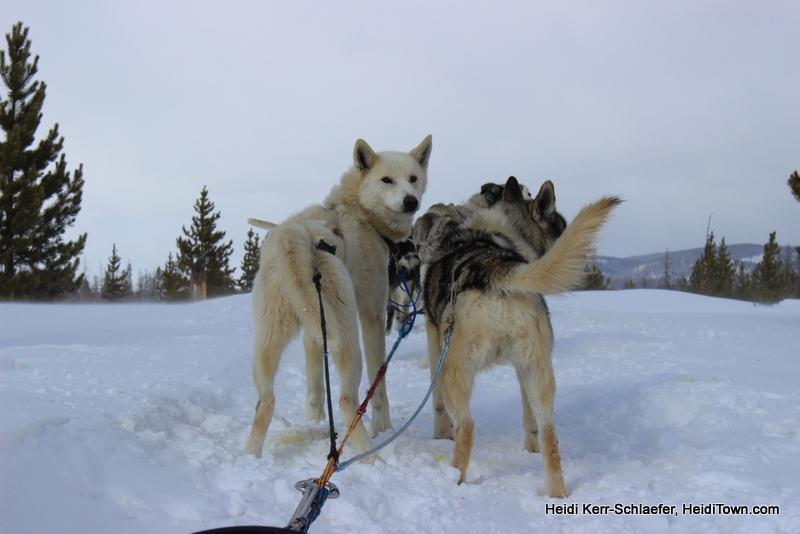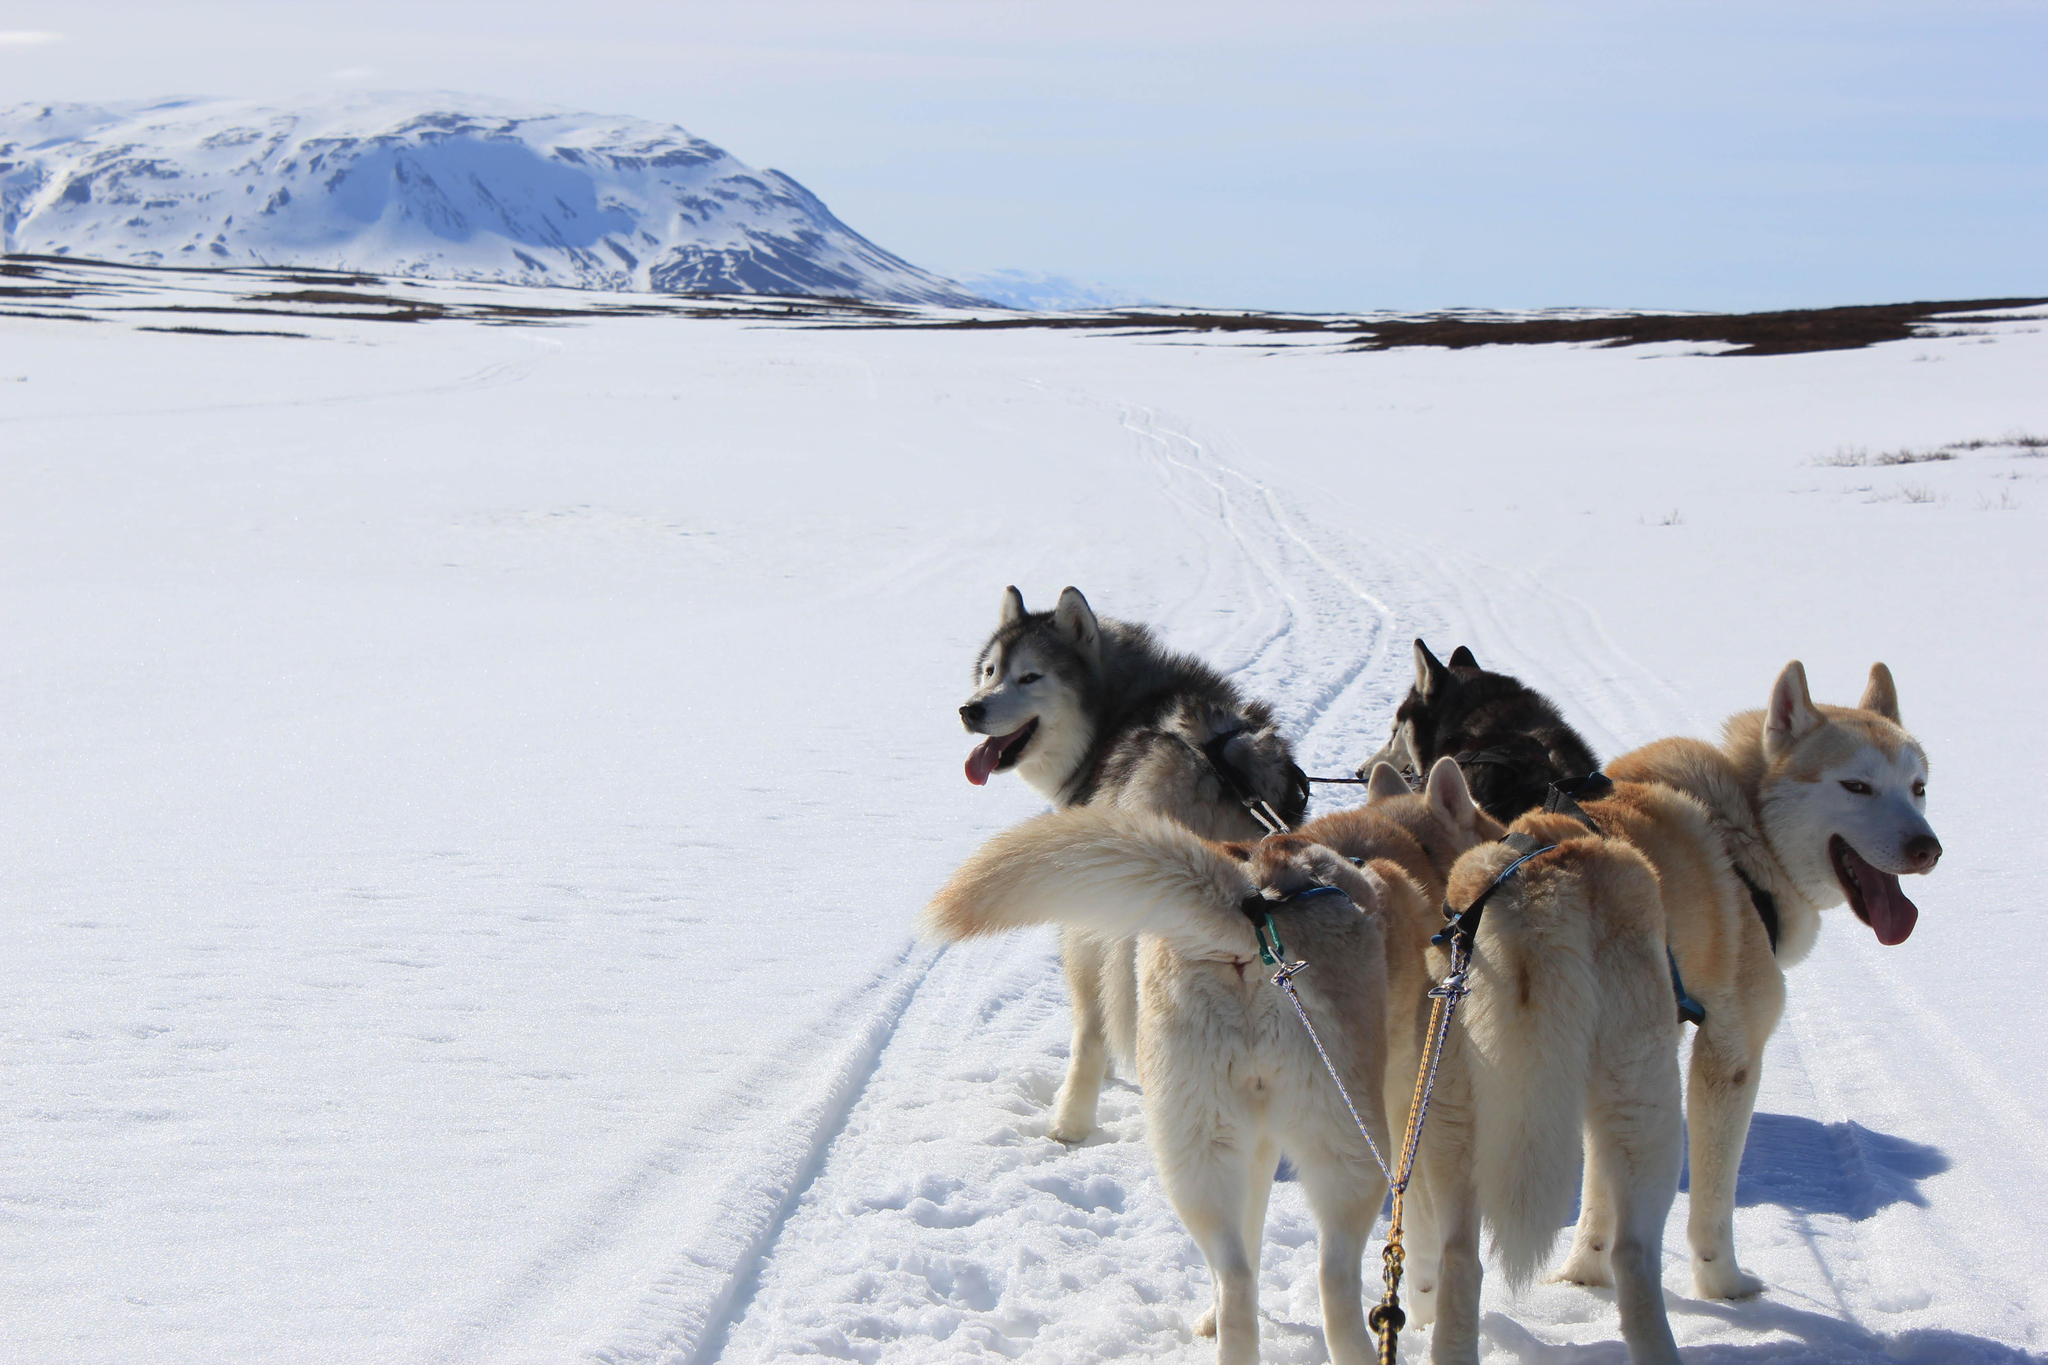The first image is the image on the left, the second image is the image on the right. Evaluate the accuracy of this statement regarding the images: "The dogs in the left image are heading to the right.". Is it true? Answer yes or no. No. The first image is the image on the left, the second image is the image on the right. For the images displayed, is the sentence "The dog sled teams in the left and right images move forward at some angle and appear to be heading toward each other." factually correct? Answer yes or no. No. 